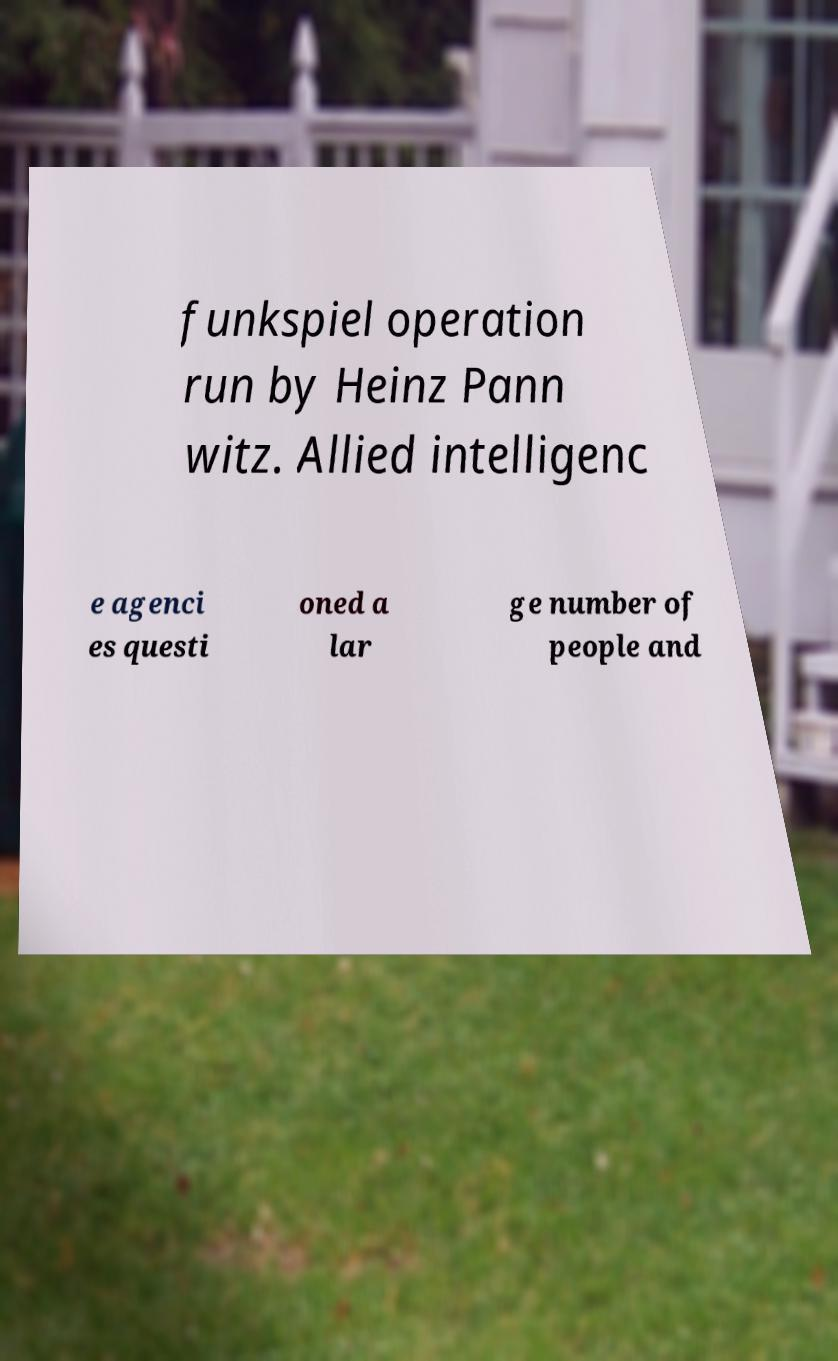There's text embedded in this image that I need extracted. Can you transcribe it verbatim? funkspiel operation run by Heinz Pann witz. Allied intelligenc e agenci es questi oned a lar ge number of people and 